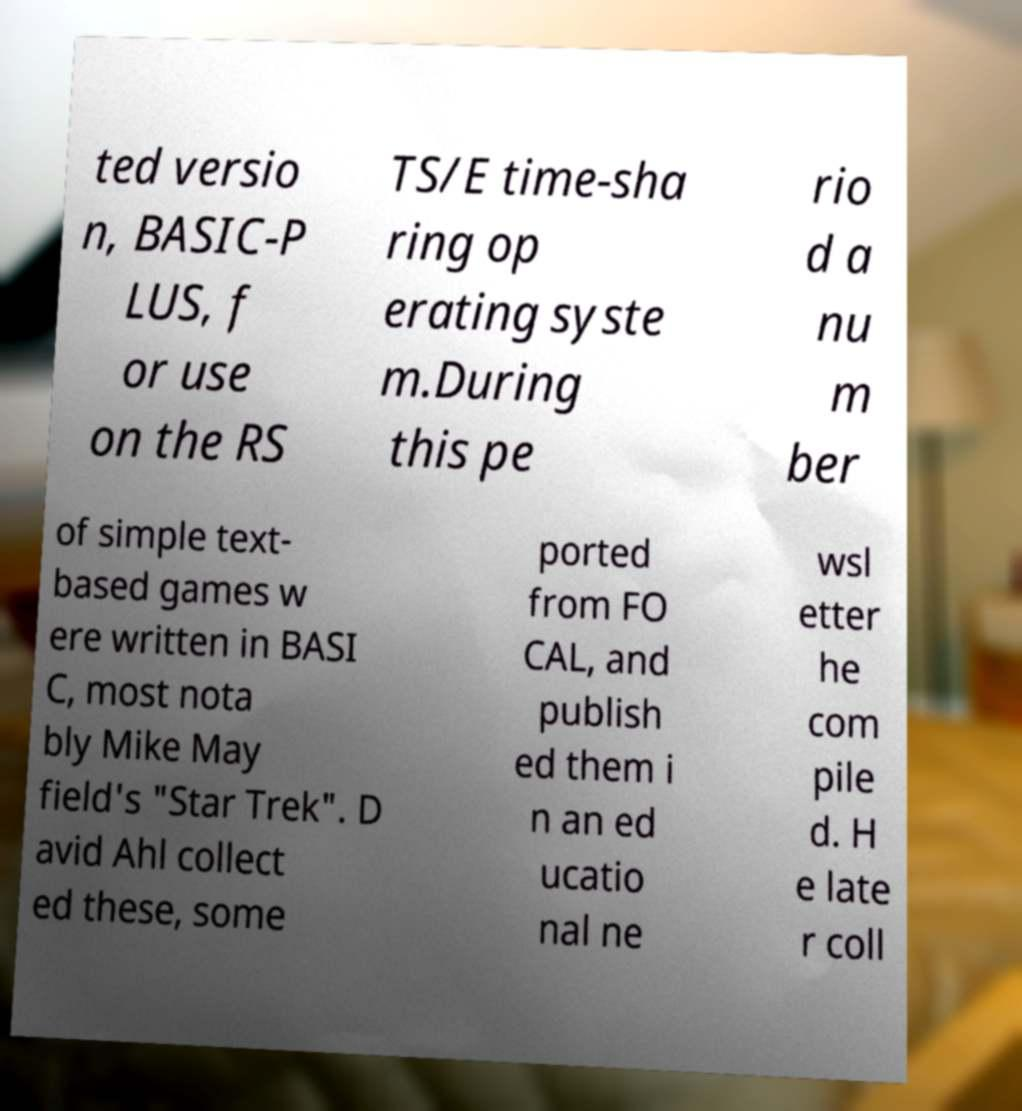Could you assist in decoding the text presented in this image and type it out clearly? ted versio n, BASIC-P LUS, f or use on the RS TS/E time-sha ring op erating syste m.During this pe rio d a nu m ber of simple text- based games w ere written in BASI C, most nota bly Mike May field's "Star Trek". D avid Ahl collect ed these, some ported from FO CAL, and publish ed them i n an ed ucatio nal ne wsl etter he com pile d. H e late r coll 